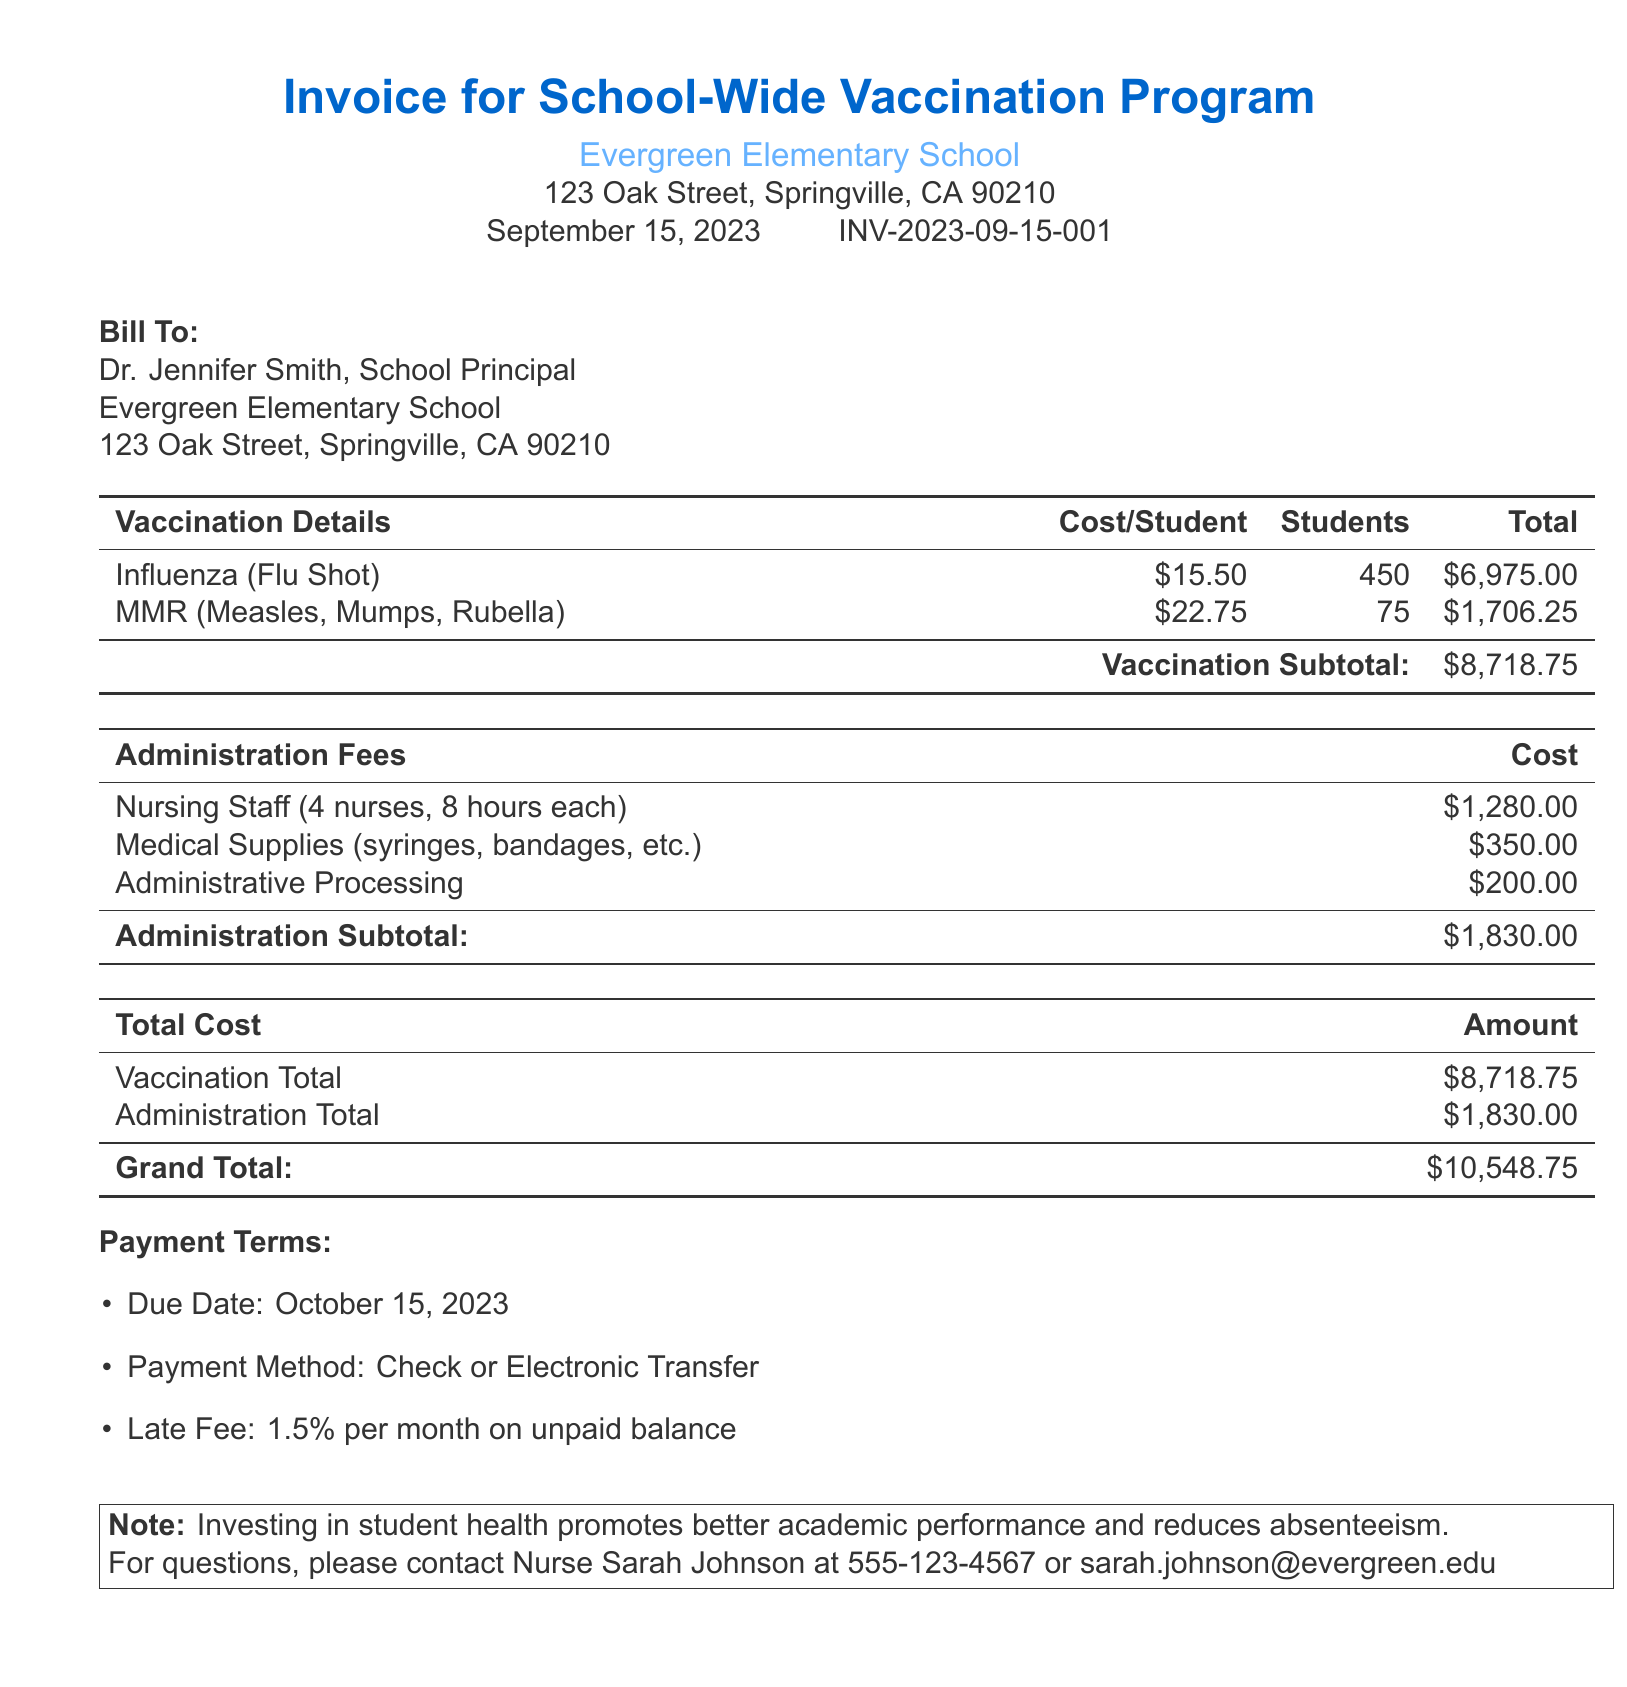What is the total number of students receiving the flu shot? The document states that 450 students are receiving the flu shot.
Answer: 450 What is the cost of the MMR vaccination per student? The document lists the cost of the MMR vaccination as $22.75.
Answer: $22.75 What is the subtotal for vaccination costs? The subtotal for vaccination costs is calculated and shown as $8,718.75 in the document.
Answer: $8,718.75 How many nurses were employed for the administration of the vaccinations? The document mentions that 4 nurses were utilized for the vaccination program.
Answer: 4 What is the total administration cost? The document summarizes the administration cost as $1,830.00.
Answer: $1,830.00 What is the grand total for the vaccination program? The grand total for the vaccination program is clearly stated in the document as $10,548.75.
Answer: $10,548.75 What are the payment terms due date? The payment terms specify that the due date is October 15, 2023.
Answer: October 15, 2023 Who should be contacted for questions regarding the invoice? The document provides the contact name as Nurse Sarah Johnson for any inquiries.
Answer: Nurse Sarah Johnson What percentage is the late fee for an unpaid balance? The document indicates that the late fee is 1.5% per month on the unpaid balance.
Answer: 1.5% 